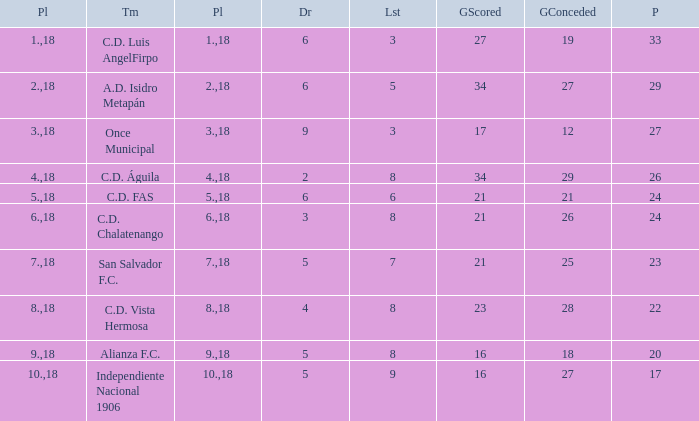What is the minimum number of goals scored with over 19 goals conceded and fewer than 18 played? None. 